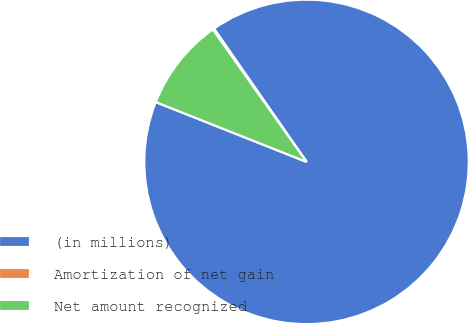<chart> <loc_0><loc_0><loc_500><loc_500><pie_chart><fcel>(in millions)<fcel>Amortization of net gain<fcel>Net amount recognized<nl><fcel>90.68%<fcel>0.14%<fcel>9.19%<nl></chart> 